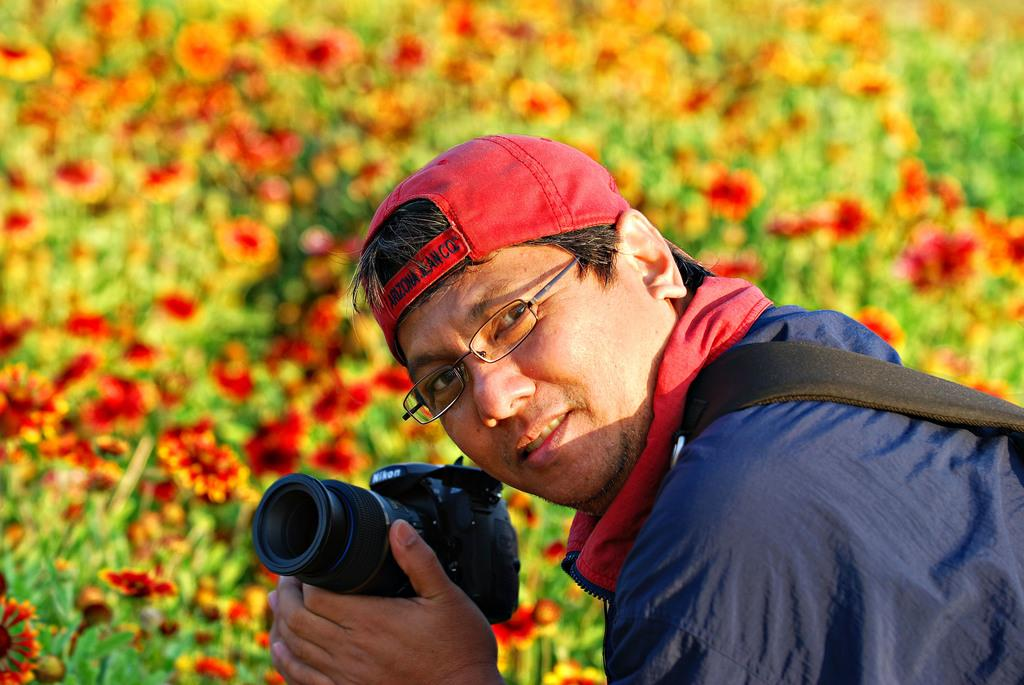What is the main subject of the image? There is a person in the image. What is the person wearing on their head? The person is wearing a cap. What is the person holding in their hands? The person is holding a camera. Where is the person located in relation to the flower garden? The person is beside a flower garden. Is the person in the image celebrating their birthday? There is no indication in the image that the person is celebrating their birthday. What type of sponge can be seen in the image? There is no sponge present in the image. 